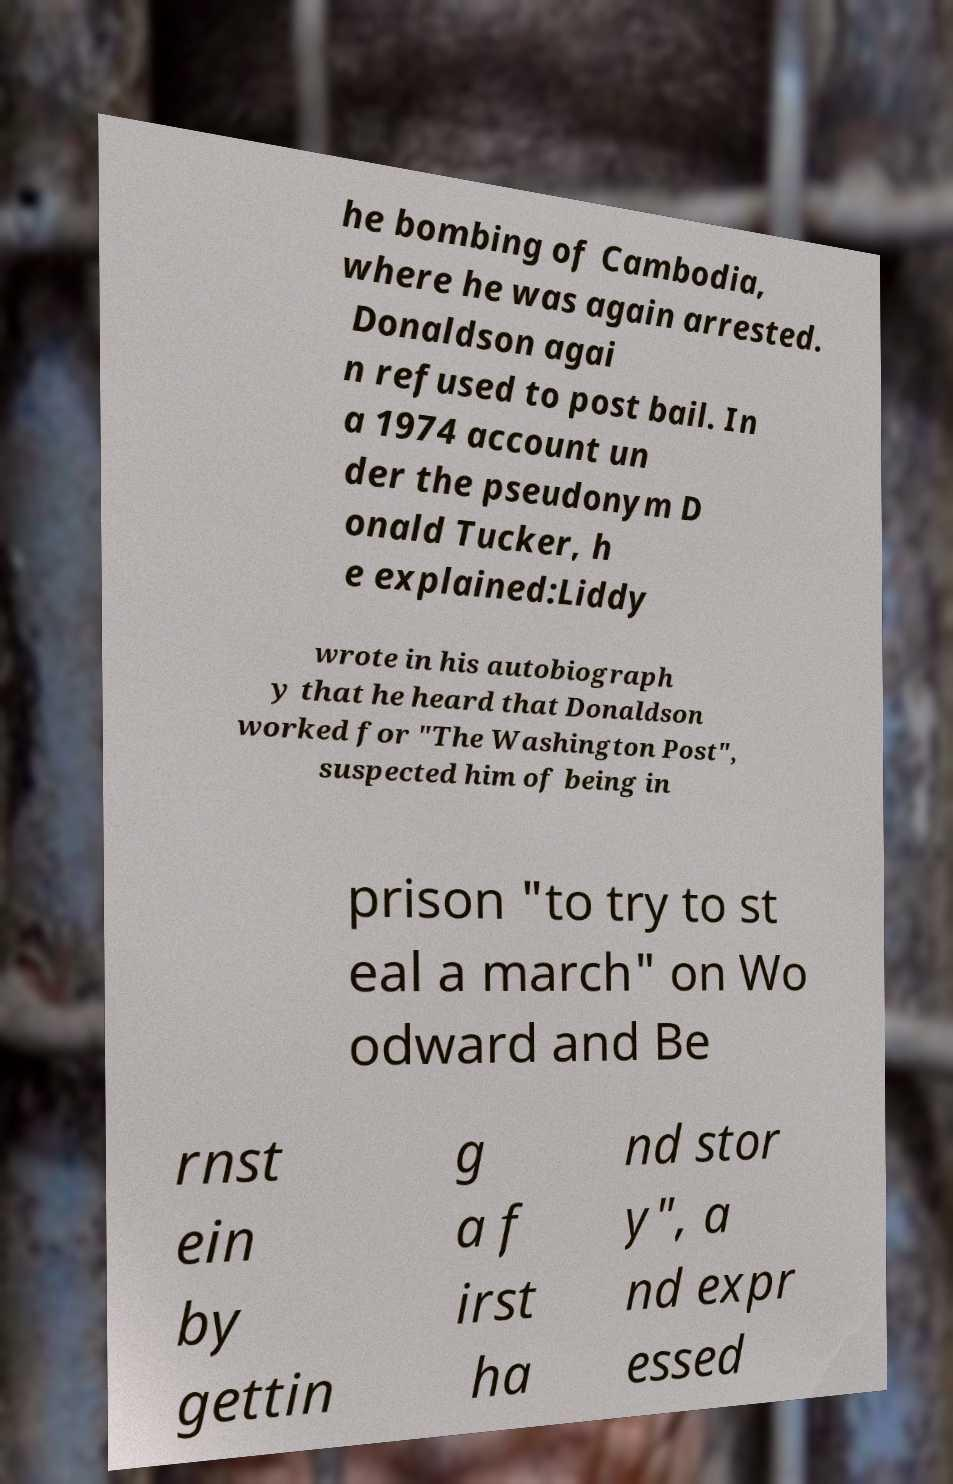Please read and relay the text visible in this image. What does it say? he bombing of Cambodia, where he was again arrested. Donaldson agai n refused to post bail. In a 1974 account un der the pseudonym D onald Tucker, h e explained:Liddy wrote in his autobiograph y that he heard that Donaldson worked for "The Washington Post", suspected him of being in prison "to try to st eal a march" on Wo odward and Be rnst ein by gettin g a f irst ha nd stor y", a nd expr essed 